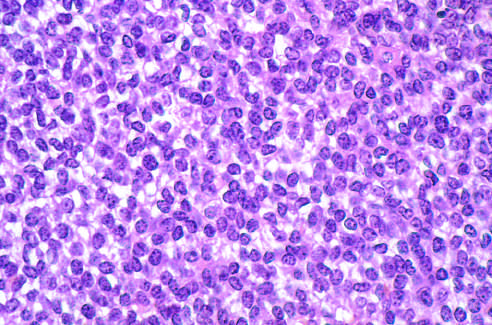how is ewing sarcoma composed of sheets of small round cells?
Answer the question using a single word or phrase. With small amounts of clear cytoplasm 